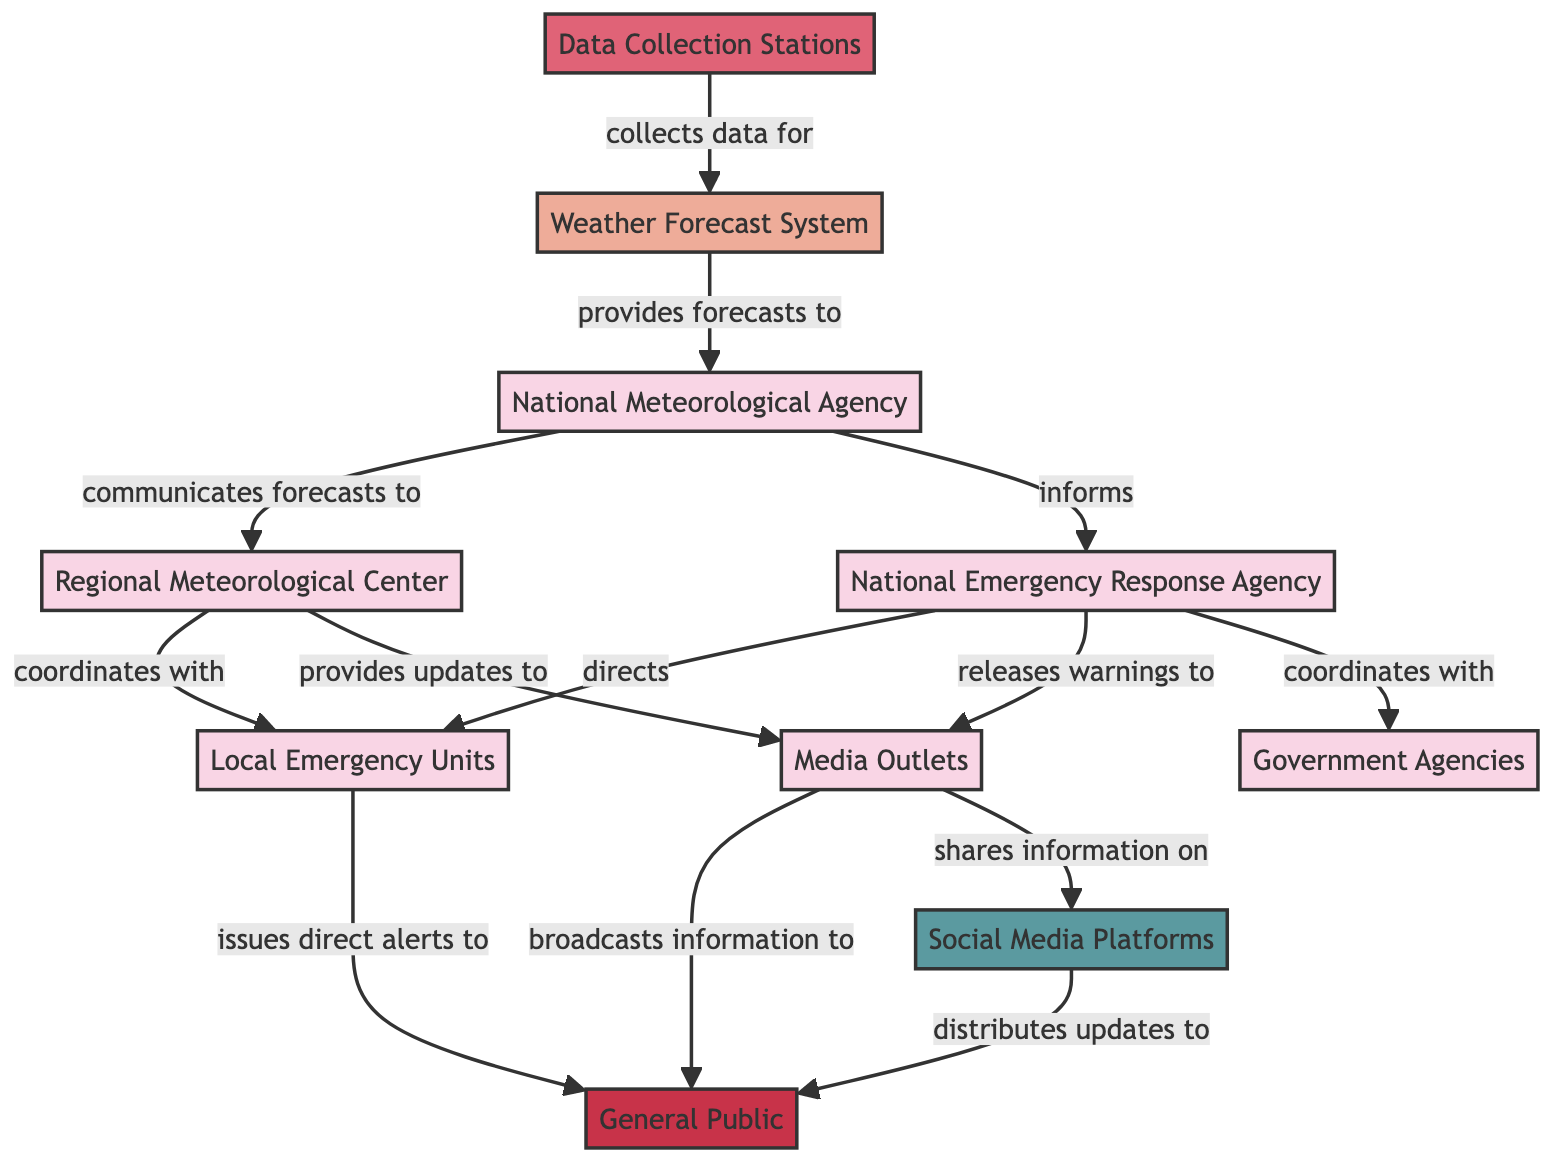What is the total number of nodes in the diagram? The nodes are: National Meteorological Agency, Regional Meteorological Center, Weather Forecast System, Data Collection Stations, National Emergency Response Agency, Local Emergency Units, Media Outlets, General Public, Social Media Platforms, and Government Agencies. Counting these gives a total of 10 nodes.
Answer: 10 Which node provides forecasts to the National Meteorological Agency? The Weather Forecast System is indicated to provide forecasts to the National Meteorological Agency in the diagram.
Answer: Weather Forecast System What type of communication occurs between the National Meteorological Agency and the Emergency Response Agency? The diagram shows that the National Meteorological Agency informs the Emergency Response Agency through a communication channel.
Answer: informs How many edges are connected to the Local Emergency Units? The edges connected to Local Emergency Units are from Regional Meteorological Center and Emergency Response Agency, totaling 2 edges.
Answer: 2 What is the relationship between Media Outlets and the General Public? The Media Outlets broadcasts information to the General Public, creating a direct communication link in the diagram.
Answer: broadcasts information to Which organization coordinates with the Government Agencies? The National Emergency Response Agency is shown to coordinate with Government Agencies, indicating a structured connection.
Answer: National Emergency Response Agency What is the last step in the information flow that reaches the General Public? The last step is that Social Media Platforms distribute updates to the General Public, making this the final communication point for the public.
Answer: distributes updates to Which node has relationships with both Media Outlets and Social Media Platforms? Media Outlets shares information on Social Media Platforms, indicating that both nodes have a relationship of media flow and communication.
Answer: Media Outlets How does the Regional Meteorological Center communicate with Local Emergency Units? The Regional Meteorological Center coordinates with Local Emergency Units, showing a collaborative effort in the flow of information.
Answer: coordinates with What action does the National Emergency Response Agency take towards Media Outlets? The action taken is that the National Emergency Response Agency releases warnings to Media Outlets, establishing a direct communication pathway.
Answer: releases warnings to 